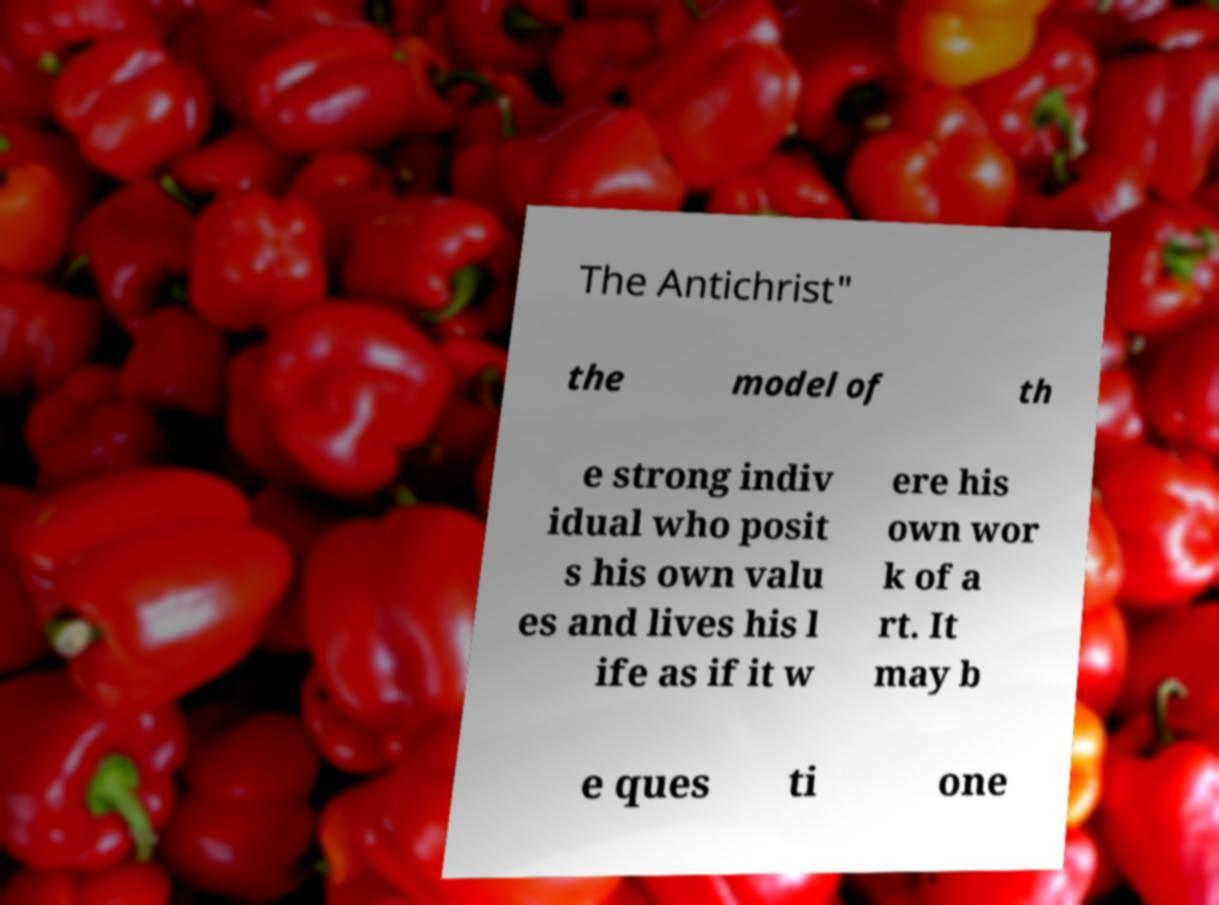Please identify and transcribe the text found in this image. The Antichrist" the model of th e strong indiv idual who posit s his own valu es and lives his l ife as if it w ere his own wor k of a rt. It may b e ques ti one 